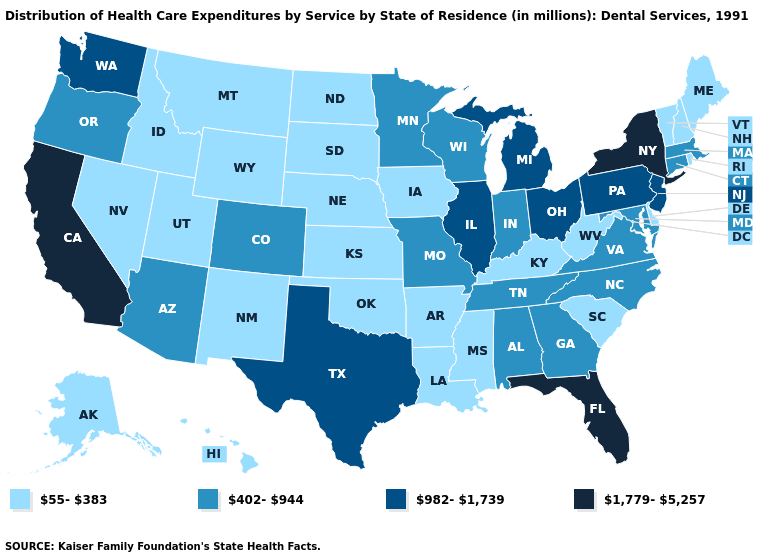Does the first symbol in the legend represent the smallest category?
Keep it brief. Yes. What is the value of North Carolina?
Keep it brief. 402-944. What is the lowest value in states that border Oklahoma?
Short answer required. 55-383. What is the highest value in the USA?
Keep it brief. 1,779-5,257. What is the value of Alabama?
Give a very brief answer. 402-944. Does California have the highest value in the USA?
Short answer required. Yes. Name the states that have a value in the range 55-383?
Be succinct. Alaska, Arkansas, Delaware, Hawaii, Idaho, Iowa, Kansas, Kentucky, Louisiana, Maine, Mississippi, Montana, Nebraska, Nevada, New Hampshire, New Mexico, North Dakota, Oklahoma, Rhode Island, South Carolina, South Dakota, Utah, Vermont, West Virginia, Wyoming. Among the states that border Nebraska , which have the lowest value?
Keep it brief. Iowa, Kansas, South Dakota, Wyoming. Which states have the lowest value in the USA?
Keep it brief. Alaska, Arkansas, Delaware, Hawaii, Idaho, Iowa, Kansas, Kentucky, Louisiana, Maine, Mississippi, Montana, Nebraska, Nevada, New Hampshire, New Mexico, North Dakota, Oklahoma, Rhode Island, South Carolina, South Dakota, Utah, Vermont, West Virginia, Wyoming. Name the states that have a value in the range 55-383?
Quick response, please. Alaska, Arkansas, Delaware, Hawaii, Idaho, Iowa, Kansas, Kentucky, Louisiana, Maine, Mississippi, Montana, Nebraska, Nevada, New Hampshire, New Mexico, North Dakota, Oklahoma, Rhode Island, South Carolina, South Dakota, Utah, Vermont, West Virginia, Wyoming. Name the states that have a value in the range 982-1,739?
Quick response, please. Illinois, Michigan, New Jersey, Ohio, Pennsylvania, Texas, Washington. What is the lowest value in the USA?
Concise answer only. 55-383. Does Michigan have the highest value in the MidWest?
Give a very brief answer. Yes. Name the states that have a value in the range 982-1,739?
Be succinct. Illinois, Michigan, New Jersey, Ohio, Pennsylvania, Texas, Washington. Does Virginia have the same value as Hawaii?
Short answer required. No. 